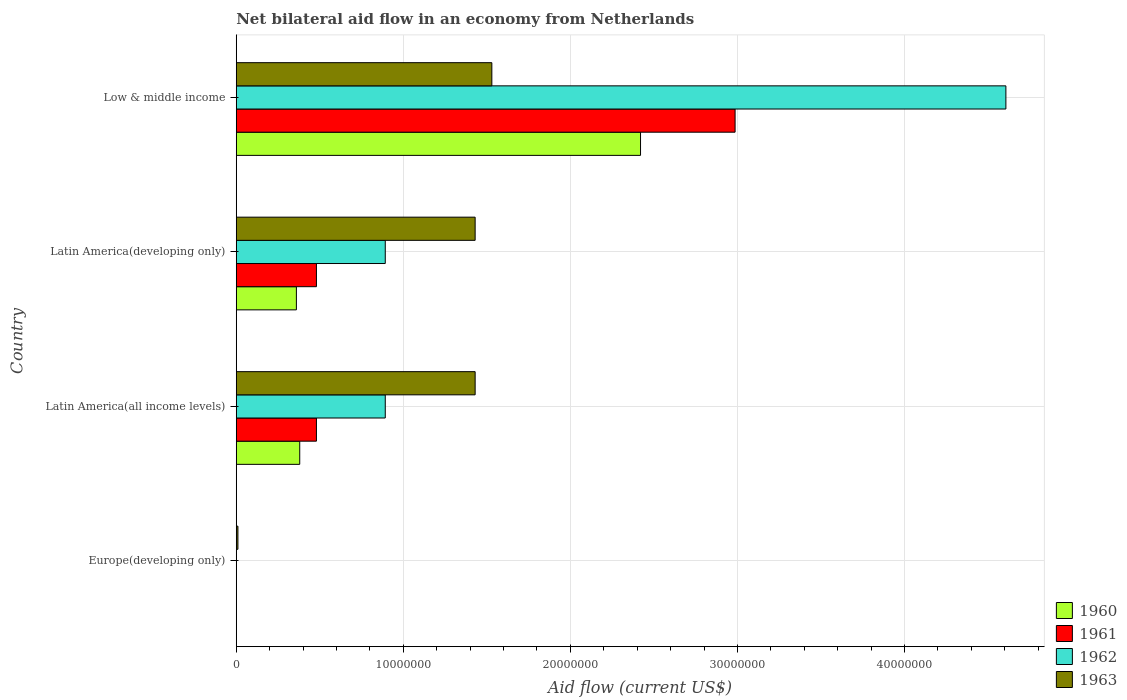Are the number of bars per tick equal to the number of legend labels?
Offer a very short reply. No. What is the label of the 3rd group of bars from the top?
Your answer should be compact. Latin America(all income levels). In how many cases, is the number of bars for a given country not equal to the number of legend labels?
Provide a short and direct response. 1. What is the net bilateral aid flow in 1960 in Europe(developing only)?
Give a very brief answer. 0. Across all countries, what is the maximum net bilateral aid flow in 1960?
Your response must be concise. 2.42e+07. Across all countries, what is the minimum net bilateral aid flow in 1963?
Your response must be concise. 1.00e+05. In which country was the net bilateral aid flow in 1962 maximum?
Ensure brevity in your answer.  Low & middle income. What is the total net bilateral aid flow in 1962 in the graph?
Your response must be concise. 6.39e+07. What is the difference between the net bilateral aid flow in 1963 in Latin America(all income levels) and the net bilateral aid flow in 1960 in Europe(developing only)?
Offer a terse response. 1.43e+07. What is the average net bilateral aid flow in 1962 per country?
Make the answer very short. 1.60e+07. What is the difference between the net bilateral aid flow in 1962 and net bilateral aid flow in 1960 in Latin America(developing only)?
Your answer should be compact. 5.32e+06. What is the ratio of the net bilateral aid flow in 1960 in Latin America(all income levels) to that in Latin America(developing only)?
Give a very brief answer. 1.06. What is the difference between the highest and the second highest net bilateral aid flow in 1960?
Your answer should be very brief. 2.04e+07. What is the difference between the highest and the lowest net bilateral aid flow in 1963?
Offer a terse response. 1.52e+07. Is it the case that in every country, the sum of the net bilateral aid flow in 1962 and net bilateral aid flow in 1960 is greater than the sum of net bilateral aid flow in 1963 and net bilateral aid flow in 1961?
Keep it short and to the point. No. Are all the bars in the graph horizontal?
Offer a terse response. Yes. Are the values on the major ticks of X-axis written in scientific E-notation?
Provide a succinct answer. No. Does the graph contain any zero values?
Provide a short and direct response. Yes. Does the graph contain grids?
Offer a terse response. Yes. Where does the legend appear in the graph?
Give a very brief answer. Bottom right. How are the legend labels stacked?
Make the answer very short. Vertical. What is the title of the graph?
Your response must be concise. Net bilateral aid flow in an economy from Netherlands. Does "2010" appear as one of the legend labels in the graph?
Your answer should be compact. No. What is the label or title of the Y-axis?
Ensure brevity in your answer.  Country. What is the Aid flow (current US$) of 1962 in Europe(developing only)?
Your answer should be compact. 0. What is the Aid flow (current US$) of 1960 in Latin America(all income levels)?
Provide a short and direct response. 3.80e+06. What is the Aid flow (current US$) of 1961 in Latin America(all income levels)?
Offer a very short reply. 4.80e+06. What is the Aid flow (current US$) in 1962 in Latin America(all income levels)?
Give a very brief answer. 8.92e+06. What is the Aid flow (current US$) in 1963 in Latin America(all income levels)?
Make the answer very short. 1.43e+07. What is the Aid flow (current US$) of 1960 in Latin America(developing only)?
Offer a very short reply. 3.60e+06. What is the Aid flow (current US$) in 1961 in Latin America(developing only)?
Offer a very short reply. 4.80e+06. What is the Aid flow (current US$) in 1962 in Latin America(developing only)?
Offer a terse response. 8.92e+06. What is the Aid flow (current US$) in 1963 in Latin America(developing only)?
Your answer should be compact. 1.43e+07. What is the Aid flow (current US$) in 1960 in Low & middle income?
Offer a terse response. 2.42e+07. What is the Aid flow (current US$) of 1961 in Low & middle income?
Give a very brief answer. 2.99e+07. What is the Aid flow (current US$) in 1962 in Low & middle income?
Offer a terse response. 4.61e+07. What is the Aid flow (current US$) of 1963 in Low & middle income?
Provide a succinct answer. 1.53e+07. Across all countries, what is the maximum Aid flow (current US$) of 1960?
Make the answer very short. 2.42e+07. Across all countries, what is the maximum Aid flow (current US$) in 1961?
Provide a short and direct response. 2.99e+07. Across all countries, what is the maximum Aid flow (current US$) of 1962?
Ensure brevity in your answer.  4.61e+07. Across all countries, what is the maximum Aid flow (current US$) in 1963?
Offer a very short reply. 1.53e+07. Across all countries, what is the minimum Aid flow (current US$) of 1963?
Your answer should be compact. 1.00e+05. What is the total Aid flow (current US$) of 1960 in the graph?
Keep it short and to the point. 3.16e+07. What is the total Aid flow (current US$) of 1961 in the graph?
Provide a short and direct response. 3.95e+07. What is the total Aid flow (current US$) in 1962 in the graph?
Your response must be concise. 6.39e+07. What is the total Aid flow (current US$) of 1963 in the graph?
Offer a very short reply. 4.40e+07. What is the difference between the Aid flow (current US$) of 1963 in Europe(developing only) and that in Latin America(all income levels)?
Offer a very short reply. -1.42e+07. What is the difference between the Aid flow (current US$) of 1963 in Europe(developing only) and that in Latin America(developing only)?
Your answer should be very brief. -1.42e+07. What is the difference between the Aid flow (current US$) in 1963 in Europe(developing only) and that in Low & middle income?
Keep it short and to the point. -1.52e+07. What is the difference between the Aid flow (current US$) in 1960 in Latin America(all income levels) and that in Latin America(developing only)?
Make the answer very short. 2.00e+05. What is the difference between the Aid flow (current US$) of 1961 in Latin America(all income levels) and that in Latin America(developing only)?
Make the answer very short. 0. What is the difference between the Aid flow (current US$) of 1963 in Latin America(all income levels) and that in Latin America(developing only)?
Give a very brief answer. 0. What is the difference between the Aid flow (current US$) of 1960 in Latin America(all income levels) and that in Low & middle income?
Give a very brief answer. -2.04e+07. What is the difference between the Aid flow (current US$) of 1961 in Latin America(all income levels) and that in Low & middle income?
Your answer should be compact. -2.51e+07. What is the difference between the Aid flow (current US$) of 1962 in Latin America(all income levels) and that in Low & middle income?
Keep it short and to the point. -3.72e+07. What is the difference between the Aid flow (current US$) of 1960 in Latin America(developing only) and that in Low & middle income?
Your answer should be compact. -2.06e+07. What is the difference between the Aid flow (current US$) of 1961 in Latin America(developing only) and that in Low & middle income?
Provide a short and direct response. -2.51e+07. What is the difference between the Aid flow (current US$) in 1962 in Latin America(developing only) and that in Low & middle income?
Offer a terse response. -3.72e+07. What is the difference between the Aid flow (current US$) of 1963 in Latin America(developing only) and that in Low & middle income?
Offer a terse response. -1.00e+06. What is the difference between the Aid flow (current US$) in 1960 in Latin America(all income levels) and the Aid flow (current US$) in 1961 in Latin America(developing only)?
Your response must be concise. -1.00e+06. What is the difference between the Aid flow (current US$) of 1960 in Latin America(all income levels) and the Aid flow (current US$) of 1962 in Latin America(developing only)?
Give a very brief answer. -5.12e+06. What is the difference between the Aid flow (current US$) in 1960 in Latin America(all income levels) and the Aid flow (current US$) in 1963 in Latin America(developing only)?
Provide a short and direct response. -1.05e+07. What is the difference between the Aid flow (current US$) in 1961 in Latin America(all income levels) and the Aid flow (current US$) in 1962 in Latin America(developing only)?
Make the answer very short. -4.12e+06. What is the difference between the Aid flow (current US$) of 1961 in Latin America(all income levels) and the Aid flow (current US$) of 1963 in Latin America(developing only)?
Offer a very short reply. -9.50e+06. What is the difference between the Aid flow (current US$) in 1962 in Latin America(all income levels) and the Aid flow (current US$) in 1963 in Latin America(developing only)?
Keep it short and to the point. -5.38e+06. What is the difference between the Aid flow (current US$) of 1960 in Latin America(all income levels) and the Aid flow (current US$) of 1961 in Low & middle income?
Your answer should be compact. -2.61e+07. What is the difference between the Aid flow (current US$) of 1960 in Latin America(all income levels) and the Aid flow (current US$) of 1962 in Low & middle income?
Your response must be concise. -4.23e+07. What is the difference between the Aid flow (current US$) of 1960 in Latin America(all income levels) and the Aid flow (current US$) of 1963 in Low & middle income?
Your answer should be compact. -1.15e+07. What is the difference between the Aid flow (current US$) of 1961 in Latin America(all income levels) and the Aid flow (current US$) of 1962 in Low & middle income?
Your response must be concise. -4.13e+07. What is the difference between the Aid flow (current US$) of 1961 in Latin America(all income levels) and the Aid flow (current US$) of 1963 in Low & middle income?
Ensure brevity in your answer.  -1.05e+07. What is the difference between the Aid flow (current US$) of 1962 in Latin America(all income levels) and the Aid flow (current US$) of 1963 in Low & middle income?
Give a very brief answer. -6.38e+06. What is the difference between the Aid flow (current US$) of 1960 in Latin America(developing only) and the Aid flow (current US$) of 1961 in Low & middle income?
Offer a very short reply. -2.63e+07. What is the difference between the Aid flow (current US$) of 1960 in Latin America(developing only) and the Aid flow (current US$) of 1962 in Low & middle income?
Your answer should be very brief. -4.25e+07. What is the difference between the Aid flow (current US$) in 1960 in Latin America(developing only) and the Aid flow (current US$) in 1963 in Low & middle income?
Your answer should be compact. -1.17e+07. What is the difference between the Aid flow (current US$) in 1961 in Latin America(developing only) and the Aid flow (current US$) in 1962 in Low & middle income?
Offer a terse response. -4.13e+07. What is the difference between the Aid flow (current US$) of 1961 in Latin America(developing only) and the Aid flow (current US$) of 1963 in Low & middle income?
Offer a very short reply. -1.05e+07. What is the difference between the Aid flow (current US$) in 1962 in Latin America(developing only) and the Aid flow (current US$) in 1963 in Low & middle income?
Provide a short and direct response. -6.38e+06. What is the average Aid flow (current US$) of 1960 per country?
Your answer should be compact. 7.90e+06. What is the average Aid flow (current US$) of 1961 per country?
Give a very brief answer. 9.86e+06. What is the average Aid flow (current US$) in 1962 per country?
Your response must be concise. 1.60e+07. What is the average Aid flow (current US$) in 1963 per country?
Provide a short and direct response. 1.10e+07. What is the difference between the Aid flow (current US$) of 1960 and Aid flow (current US$) of 1962 in Latin America(all income levels)?
Make the answer very short. -5.12e+06. What is the difference between the Aid flow (current US$) of 1960 and Aid flow (current US$) of 1963 in Latin America(all income levels)?
Ensure brevity in your answer.  -1.05e+07. What is the difference between the Aid flow (current US$) of 1961 and Aid flow (current US$) of 1962 in Latin America(all income levels)?
Offer a terse response. -4.12e+06. What is the difference between the Aid flow (current US$) in 1961 and Aid flow (current US$) in 1963 in Latin America(all income levels)?
Make the answer very short. -9.50e+06. What is the difference between the Aid flow (current US$) in 1962 and Aid flow (current US$) in 1963 in Latin America(all income levels)?
Keep it short and to the point. -5.38e+06. What is the difference between the Aid flow (current US$) in 1960 and Aid flow (current US$) in 1961 in Latin America(developing only)?
Provide a succinct answer. -1.20e+06. What is the difference between the Aid flow (current US$) of 1960 and Aid flow (current US$) of 1962 in Latin America(developing only)?
Provide a succinct answer. -5.32e+06. What is the difference between the Aid flow (current US$) of 1960 and Aid flow (current US$) of 1963 in Latin America(developing only)?
Your answer should be very brief. -1.07e+07. What is the difference between the Aid flow (current US$) of 1961 and Aid flow (current US$) of 1962 in Latin America(developing only)?
Your answer should be compact. -4.12e+06. What is the difference between the Aid flow (current US$) in 1961 and Aid flow (current US$) in 1963 in Latin America(developing only)?
Your answer should be compact. -9.50e+06. What is the difference between the Aid flow (current US$) of 1962 and Aid flow (current US$) of 1963 in Latin America(developing only)?
Make the answer very short. -5.38e+06. What is the difference between the Aid flow (current US$) of 1960 and Aid flow (current US$) of 1961 in Low & middle income?
Offer a terse response. -5.66e+06. What is the difference between the Aid flow (current US$) in 1960 and Aid flow (current US$) in 1962 in Low & middle income?
Offer a very short reply. -2.19e+07. What is the difference between the Aid flow (current US$) of 1960 and Aid flow (current US$) of 1963 in Low & middle income?
Keep it short and to the point. 8.90e+06. What is the difference between the Aid flow (current US$) in 1961 and Aid flow (current US$) in 1962 in Low & middle income?
Your response must be concise. -1.62e+07. What is the difference between the Aid flow (current US$) of 1961 and Aid flow (current US$) of 1963 in Low & middle income?
Make the answer very short. 1.46e+07. What is the difference between the Aid flow (current US$) in 1962 and Aid flow (current US$) in 1963 in Low & middle income?
Provide a short and direct response. 3.08e+07. What is the ratio of the Aid flow (current US$) of 1963 in Europe(developing only) to that in Latin America(all income levels)?
Your response must be concise. 0.01. What is the ratio of the Aid flow (current US$) in 1963 in Europe(developing only) to that in Latin America(developing only)?
Provide a succinct answer. 0.01. What is the ratio of the Aid flow (current US$) of 1963 in Europe(developing only) to that in Low & middle income?
Provide a short and direct response. 0.01. What is the ratio of the Aid flow (current US$) in 1960 in Latin America(all income levels) to that in Latin America(developing only)?
Offer a terse response. 1.06. What is the ratio of the Aid flow (current US$) in 1961 in Latin America(all income levels) to that in Latin America(developing only)?
Ensure brevity in your answer.  1. What is the ratio of the Aid flow (current US$) in 1963 in Latin America(all income levels) to that in Latin America(developing only)?
Your answer should be compact. 1. What is the ratio of the Aid flow (current US$) in 1960 in Latin America(all income levels) to that in Low & middle income?
Provide a short and direct response. 0.16. What is the ratio of the Aid flow (current US$) in 1961 in Latin America(all income levels) to that in Low & middle income?
Offer a terse response. 0.16. What is the ratio of the Aid flow (current US$) of 1962 in Latin America(all income levels) to that in Low & middle income?
Keep it short and to the point. 0.19. What is the ratio of the Aid flow (current US$) of 1963 in Latin America(all income levels) to that in Low & middle income?
Ensure brevity in your answer.  0.93. What is the ratio of the Aid flow (current US$) in 1960 in Latin America(developing only) to that in Low & middle income?
Offer a terse response. 0.15. What is the ratio of the Aid flow (current US$) of 1961 in Latin America(developing only) to that in Low & middle income?
Provide a succinct answer. 0.16. What is the ratio of the Aid flow (current US$) of 1962 in Latin America(developing only) to that in Low & middle income?
Offer a terse response. 0.19. What is the ratio of the Aid flow (current US$) in 1963 in Latin America(developing only) to that in Low & middle income?
Your answer should be compact. 0.93. What is the difference between the highest and the second highest Aid flow (current US$) of 1960?
Make the answer very short. 2.04e+07. What is the difference between the highest and the second highest Aid flow (current US$) of 1961?
Your response must be concise. 2.51e+07. What is the difference between the highest and the second highest Aid flow (current US$) in 1962?
Provide a succinct answer. 3.72e+07. What is the difference between the highest and the lowest Aid flow (current US$) of 1960?
Your answer should be compact. 2.42e+07. What is the difference between the highest and the lowest Aid flow (current US$) in 1961?
Make the answer very short. 2.99e+07. What is the difference between the highest and the lowest Aid flow (current US$) in 1962?
Provide a short and direct response. 4.61e+07. What is the difference between the highest and the lowest Aid flow (current US$) of 1963?
Provide a short and direct response. 1.52e+07. 